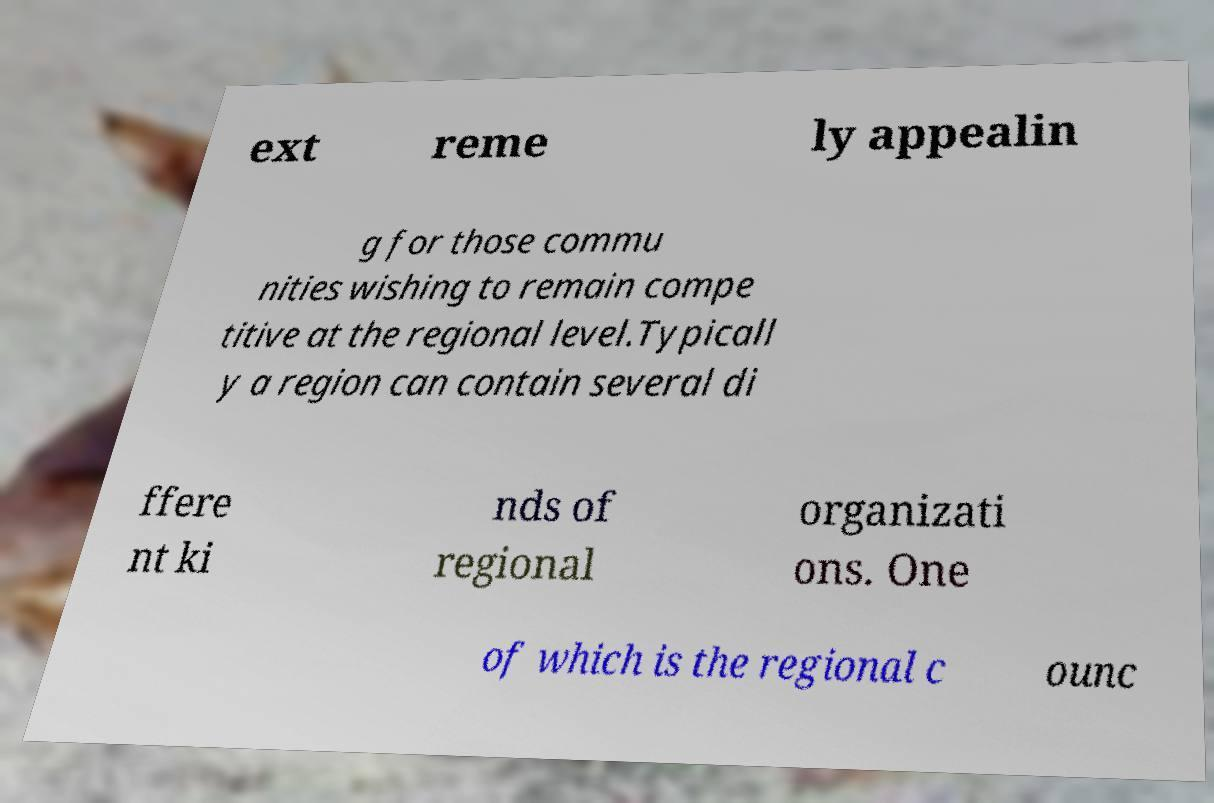Can you read and provide the text displayed in the image?This photo seems to have some interesting text. Can you extract and type it out for me? ext reme ly appealin g for those commu nities wishing to remain compe titive at the regional level.Typicall y a region can contain several di ffere nt ki nds of regional organizati ons. One of which is the regional c ounc 